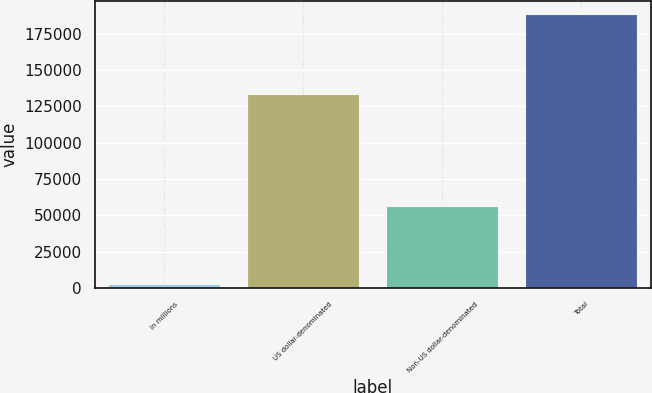Convert chart. <chart><loc_0><loc_0><loc_500><loc_500><bar_chart><fcel>in millions<fcel>US dollar-denominated<fcel>Non-US dollar-denominated<fcel>Total<nl><fcel>2015<fcel>132415<fcel>55333<fcel>187748<nl></chart> 